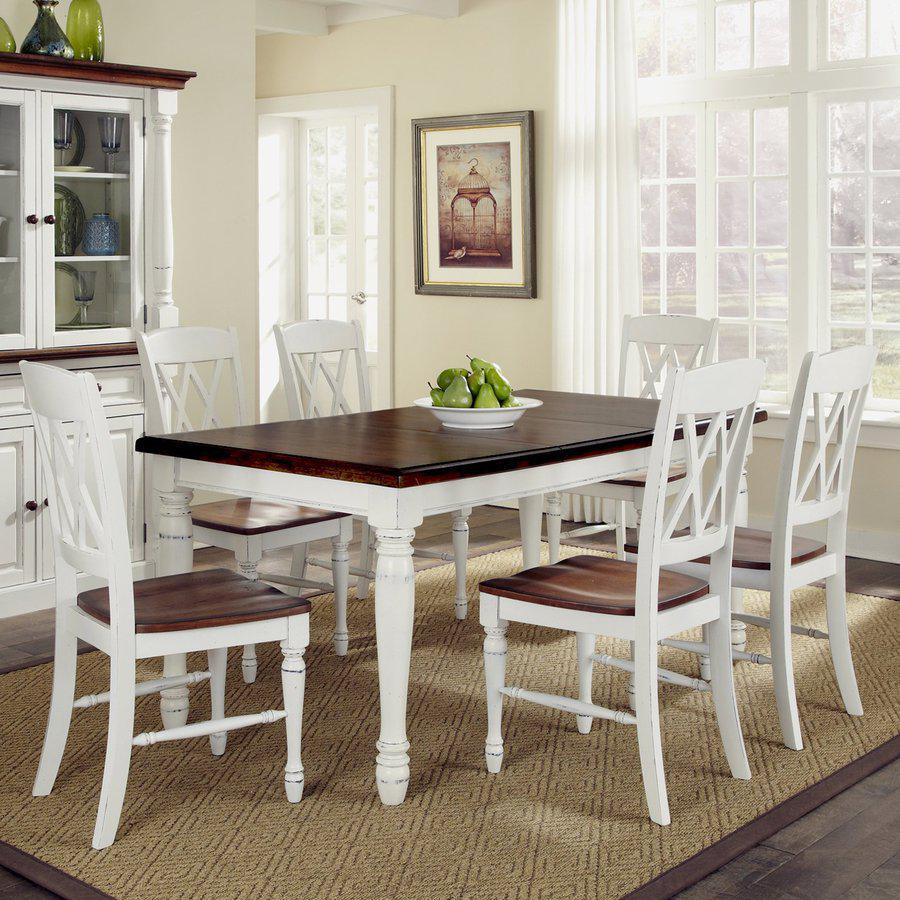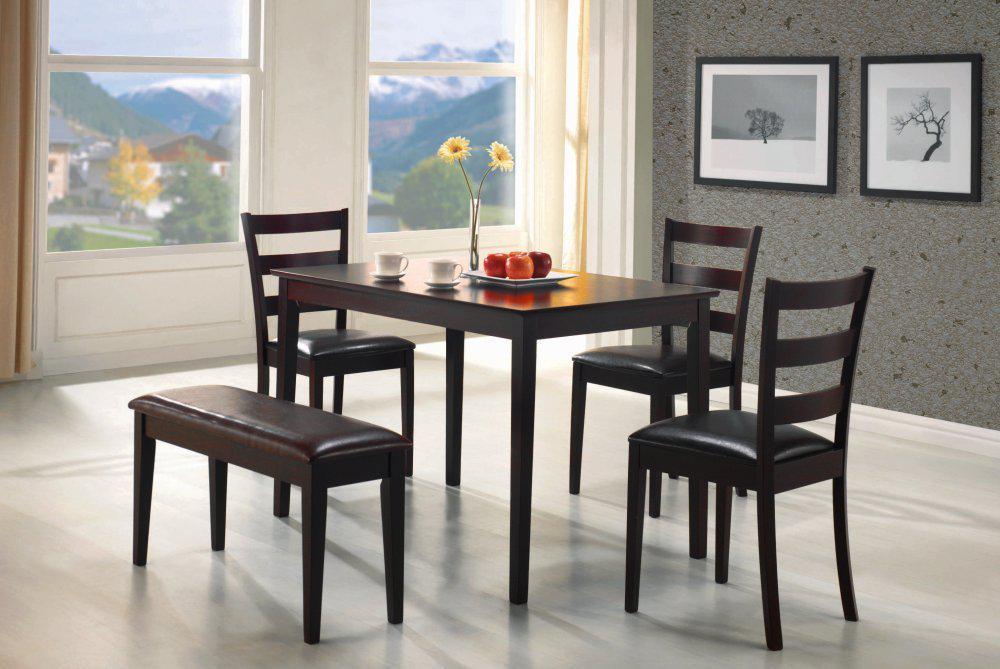The first image is the image on the left, the second image is the image on the right. Examine the images to the left and right. Is the description "One image shows a brown topped white table with six white chairs with brown seats around it, and the other image shows a non-round table with a bench on one side and at least three chairs with multiple rails across the back." accurate? Answer yes or no. Yes. The first image is the image on the left, the second image is the image on the right. Given the left and right images, does the statement "In one of the images, two different styles of seating are available around a single table." hold true? Answer yes or no. Yes. 